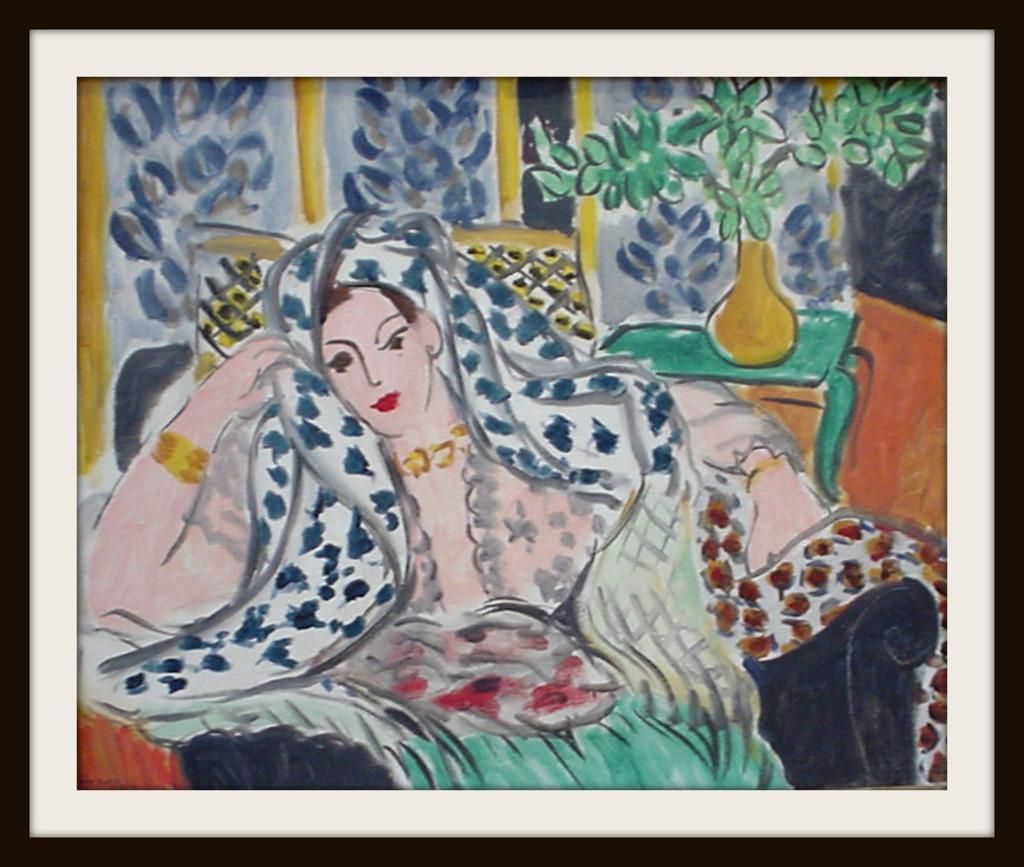What is the main subject of the image? There is a painting in the image. What does the painting depict? The painting depicts a person. What surrounds the painting in the image? The painting has a frame. How many pies are being carried by the person in the painting? There is no mention of pies in the image or the painting, as the painting depicts a person without any additional objects. 